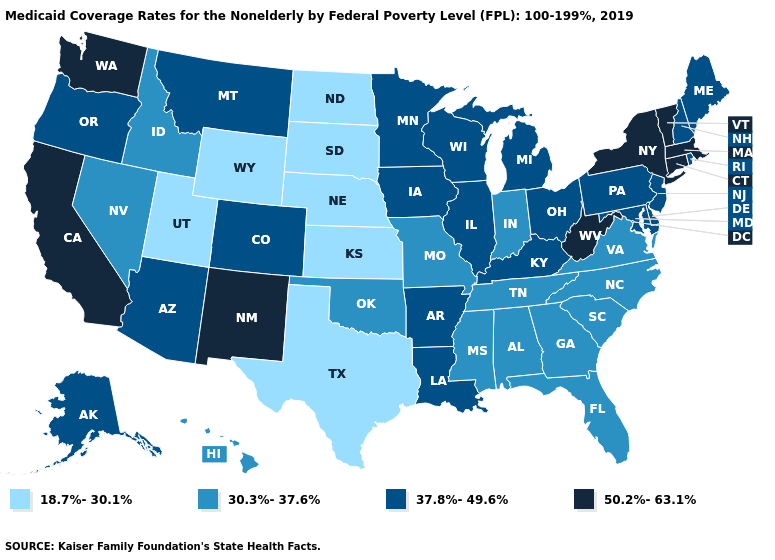How many symbols are there in the legend?
Quick response, please. 4. What is the highest value in the USA?
Be succinct. 50.2%-63.1%. What is the lowest value in states that border Illinois?
Short answer required. 30.3%-37.6%. Does North Dakota have the lowest value in the USA?
Quick response, please. Yes. What is the value of Delaware?
Give a very brief answer. 37.8%-49.6%. Does Indiana have the lowest value in the USA?
Write a very short answer. No. How many symbols are there in the legend?
Answer briefly. 4. Is the legend a continuous bar?
Concise answer only. No. What is the highest value in states that border Wyoming?
Keep it brief. 37.8%-49.6%. Among the states that border Montana , which have the highest value?
Give a very brief answer. Idaho. Name the states that have a value in the range 18.7%-30.1%?
Write a very short answer. Kansas, Nebraska, North Dakota, South Dakota, Texas, Utah, Wyoming. What is the value of Rhode Island?
Keep it brief. 37.8%-49.6%. Name the states that have a value in the range 37.8%-49.6%?
Quick response, please. Alaska, Arizona, Arkansas, Colorado, Delaware, Illinois, Iowa, Kentucky, Louisiana, Maine, Maryland, Michigan, Minnesota, Montana, New Hampshire, New Jersey, Ohio, Oregon, Pennsylvania, Rhode Island, Wisconsin. 